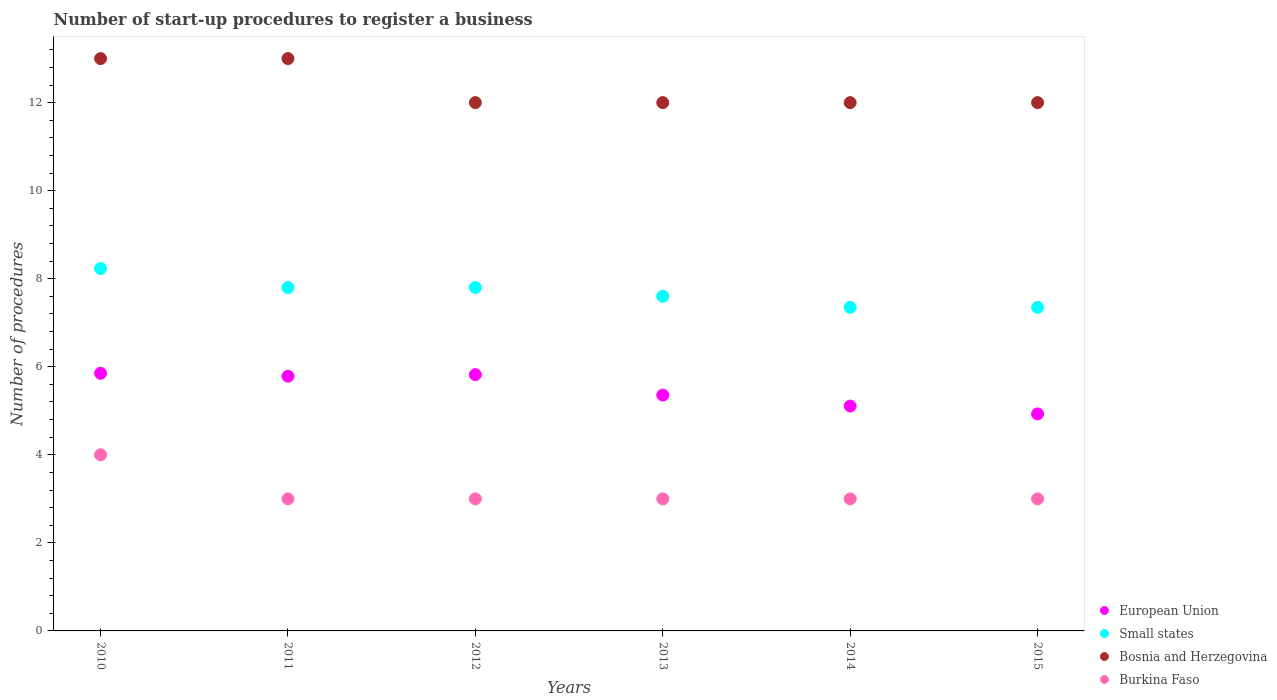Is the number of dotlines equal to the number of legend labels?
Make the answer very short. Yes. What is the number of procedures required to register a business in European Union in 2010?
Ensure brevity in your answer.  5.85. Across all years, what is the maximum number of procedures required to register a business in Small states?
Offer a terse response. 8.23. Across all years, what is the minimum number of procedures required to register a business in Small states?
Give a very brief answer. 7.35. What is the total number of procedures required to register a business in Small states in the graph?
Provide a short and direct response. 46.13. What is the difference between the number of procedures required to register a business in Burkina Faso in 2011 and that in 2012?
Offer a very short reply. 0. What is the difference between the number of procedures required to register a business in Burkina Faso in 2011 and the number of procedures required to register a business in Small states in 2015?
Provide a short and direct response. -4.35. What is the average number of procedures required to register a business in European Union per year?
Provide a succinct answer. 5.48. In the year 2012, what is the difference between the number of procedures required to register a business in Burkina Faso and number of procedures required to register a business in Small states?
Offer a terse response. -4.8. What is the ratio of the number of procedures required to register a business in European Union in 2013 to that in 2014?
Provide a succinct answer. 1.05. Is the number of procedures required to register a business in Small states in 2010 less than that in 2013?
Provide a succinct answer. No. What is the difference between the highest and the second highest number of procedures required to register a business in Small states?
Offer a very short reply. 0.43. What is the difference between the highest and the lowest number of procedures required to register a business in Small states?
Provide a short and direct response. 0.88. Is it the case that in every year, the sum of the number of procedures required to register a business in Small states and number of procedures required to register a business in Bosnia and Herzegovina  is greater than the sum of number of procedures required to register a business in European Union and number of procedures required to register a business in Burkina Faso?
Your response must be concise. Yes. Is it the case that in every year, the sum of the number of procedures required to register a business in Small states and number of procedures required to register a business in Bosnia and Herzegovina  is greater than the number of procedures required to register a business in European Union?
Ensure brevity in your answer.  Yes. Is the number of procedures required to register a business in Burkina Faso strictly less than the number of procedures required to register a business in European Union over the years?
Offer a very short reply. Yes. What is the difference between two consecutive major ticks on the Y-axis?
Your answer should be compact. 2. Does the graph contain any zero values?
Your answer should be very brief. No. Where does the legend appear in the graph?
Your answer should be very brief. Bottom right. How many legend labels are there?
Make the answer very short. 4. What is the title of the graph?
Give a very brief answer. Number of start-up procedures to register a business. What is the label or title of the X-axis?
Provide a succinct answer. Years. What is the label or title of the Y-axis?
Make the answer very short. Number of procedures. What is the Number of procedures of European Union in 2010?
Give a very brief answer. 5.85. What is the Number of procedures in Small states in 2010?
Your answer should be very brief. 8.23. What is the Number of procedures in Bosnia and Herzegovina in 2010?
Make the answer very short. 13. What is the Number of procedures of European Union in 2011?
Keep it short and to the point. 5.79. What is the Number of procedures in European Union in 2012?
Offer a very short reply. 5.82. What is the Number of procedures of Small states in 2012?
Your response must be concise. 7.8. What is the Number of procedures of Burkina Faso in 2012?
Offer a very short reply. 3. What is the Number of procedures of European Union in 2013?
Keep it short and to the point. 5.36. What is the Number of procedures in Bosnia and Herzegovina in 2013?
Your answer should be compact. 12. What is the Number of procedures of Burkina Faso in 2013?
Provide a succinct answer. 3. What is the Number of procedures in European Union in 2014?
Offer a very short reply. 5.11. What is the Number of procedures in Small states in 2014?
Keep it short and to the point. 7.35. What is the Number of procedures of Bosnia and Herzegovina in 2014?
Ensure brevity in your answer.  12. What is the Number of procedures in Burkina Faso in 2014?
Make the answer very short. 3. What is the Number of procedures of European Union in 2015?
Your response must be concise. 4.93. What is the Number of procedures of Small states in 2015?
Your response must be concise. 7.35. Across all years, what is the maximum Number of procedures in European Union?
Keep it short and to the point. 5.85. Across all years, what is the maximum Number of procedures of Small states?
Your answer should be compact. 8.23. Across all years, what is the maximum Number of procedures of Burkina Faso?
Provide a succinct answer. 4. Across all years, what is the minimum Number of procedures in European Union?
Provide a short and direct response. 4.93. Across all years, what is the minimum Number of procedures in Small states?
Your answer should be very brief. 7.35. Across all years, what is the minimum Number of procedures in Bosnia and Herzegovina?
Keep it short and to the point. 12. What is the total Number of procedures of European Union in the graph?
Make the answer very short. 32.85. What is the total Number of procedures of Small states in the graph?
Your answer should be compact. 46.13. What is the difference between the Number of procedures of European Union in 2010 and that in 2011?
Ensure brevity in your answer.  0.07. What is the difference between the Number of procedures in Small states in 2010 and that in 2011?
Make the answer very short. 0.43. What is the difference between the Number of procedures in Burkina Faso in 2010 and that in 2011?
Give a very brief answer. 1. What is the difference between the Number of procedures of European Union in 2010 and that in 2012?
Your answer should be compact. 0.03. What is the difference between the Number of procedures in Small states in 2010 and that in 2012?
Provide a succinct answer. 0.43. What is the difference between the Number of procedures of Burkina Faso in 2010 and that in 2012?
Offer a terse response. 1. What is the difference between the Number of procedures in European Union in 2010 and that in 2013?
Your response must be concise. 0.49. What is the difference between the Number of procedures in Small states in 2010 and that in 2013?
Your answer should be very brief. 0.63. What is the difference between the Number of procedures of Burkina Faso in 2010 and that in 2013?
Offer a very short reply. 1. What is the difference between the Number of procedures in European Union in 2010 and that in 2014?
Offer a very short reply. 0.74. What is the difference between the Number of procedures of Small states in 2010 and that in 2014?
Provide a succinct answer. 0.88. What is the difference between the Number of procedures in Burkina Faso in 2010 and that in 2014?
Keep it short and to the point. 1. What is the difference between the Number of procedures of European Union in 2010 and that in 2015?
Offer a terse response. 0.92. What is the difference between the Number of procedures in Small states in 2010 and that in 2015?
Offer a terse response. 0.88. What is the difference between the Number of procedures of Burkina Faso in 2010 and that in 2015?
Your answer should be very brief. 1. What is the difference between the Number of procedures of European Union in 2011 and that in 2012?
Give a very brief answer. -0.04. What is the difference between the Number of procedures of Small states in 2011 and that in 2012?
Offer a very short reply. 0. What is the difference between the Number of procedures in Bosnia and Herzegovina in 2011 and that in 2012?
Make the answer very short. 1. What is the difference between the Number of procedures of European Union in 2011 and that in 2013?
Provide a succinct answer. 0.43. What is the difference between the Number of procedures of European Union in 2011 and that in 2014?
Your answer should be compact. 0.68. What is the difference between the Number of procedures in Small states in 2011 and that in 2014?
Give a very brief answer. 0.45. What is the difference between the Number of procedures in Burkina Faso in 2011 and that in 2014?
Offer a terse response. 0. What is the difference between the Number of procedures in European Union in 2011 and that in 2015?
Offer a terse response. 0.86. What is the difference between the Number of procedures of Small states in 2011 and that in 2015?
Keep it short and to the point. 0.45. What is the difference between the Number of procedures of European Union in 2012 and that in 2013?
Ensure brevity in your answer.  0.46. What is the difference between the Number of procedures in Bosnia and Herzegovina in 2012 and that in 2013?
Give a very brief answer. 0. What is the difference between the Number of procedures of European Union in 2012 and that in 2014?
Offer a terse response. 0.71. What is the difference between the Number of procedures of Small states in 2012 and that in 2014?
Give a very brief answer. 0.45. What is the difference between the Number of procedures of Bosnia and Herzegovina in 2012 and that in 2014?
Offer a terse response. 0. What is the difference between the Number of procedures in Burkina Faso in 2012 and that in 2014?
Give a very brief answer. 0. What is the difference between the Number of procedures in European Union in 2012 and that in 2015?
Your answer should be very brief. 0.89. What is the difference between the Number of procedures in Small states in 2012 and that in 2015?
Your answer should be compact. 0.45. What is the difference between the Number of procedures in Bosnia and Herzegovina in 2012 and that in 2015?
Your answer should be compact. 0. What is the difference between the Number of procedures in Small states in 2013 and that in 2014?
Provide a short and direct response. 0.25. What is the difference between the Number of procedures of Bosnia and Herzegovina in 2013 and that in 2014?
Provide a succinct answer. 0. What is the difference between the Number of procedures of Burkina Faso in 2013 and that in 2014?
Offer a very short reply. 0. What is the difference between the Number of procedures of European Union in 2013 and that in 2015?
Your answer should be compact. 0.43. What is the difference between the Number of procedures in Small states in 2013 and that in 2015?
Give a very brief answer. 0.25. What is the difference between the Number of procedures in European Union in 2014 and that in 2015?
Offer a terse response. 0.18. What is the difference between the Number of procedures in Small states in 2014 and that in 2015?
Offer a very short reply. 0. What is the difference between the Number of procedures in European Union in 2010 and the Number of procedures in Small states in 2011?
Provide a succinct answer. -1.95. What is the difference between the Number of procedures in European Union in 2010 and the Number of procedures in Bosnia and Herzegovina in 2011?
Provide a succinct answer. -7.15. What is the difference between the Number of procedures of European Union in 2010 and the Number of procedures of Burkina Faso in 2011?
Your answer should be compact. 2.85. What is the difference between the Number of procedures in Small states in 2010 and the Number of procedures in Bosnia and Herzegovina in 2011?
Keep it short and to the point. -4.77. What is the difference between the Number of procedures in Small states in 2010 and the Number of procedures in Burkina Faso in 2011?
Offer a terse response. 5.23. What is the difference between the Number of procedures in Bosnia and Herzegovina in 2010 and the Number of procedures in Burkina Faso in 2011?
Offer a terse response. 10. What is the difference between the Number of procedures in European Union in 2010 and the Number of procedures in Small states in 2012?
Keep it short and to the point. -1.95. What is the difference between the Number of procedures in European Union in 2010 and the Number of procedures in Bosnia and Herzegovina in 2012?
Make the answer very short. -6.15. What is the difference between the Number of procedures in European Union in 2010 and the Number of procedures in Burkina Faso in 2012?
Ensure brevity in your answer.  2.85. What is the difference between the Number of procedures of Small states in 2010 and the Number of procedures of Bosnia and Herzegovina in 2012?
Ensure brevity in your answer.  -3.77. What is the difference between the Number of procedures of Small states in 2010 and the Number of procedures of Burkina Faso in 2012?
Keep it short and to the point. 5.23. What is the difference between the Number of procedures in European Union in 2010 and the Number of procedures in Small states in 2013?
Your answer should be compact. -1.75. What is the difference between the Number of procedures of European Union in 2010 and the Number of procedures of Bosnia and Herzegovina in 2013?
Give a very brief answer. -6.15. What is the difference between the Number of procedures in European Union in 2010 and the Number of procedures in Burkina Faso in 2013?
Offer a very short reply. 2.85. What is the difference between the Number of procedures in Small states in 2010 and the Number of procedures in Bosnia and Herzegovina in 2013?
Your response must be concise. -3.77. What is the difference between the Number of procedures in Small states in 2010 and the Number of procedures in Burkina Faso in 2013?
Ensure brevity in your answer.  5.23. What is the difference between the Number of procedures in Bosnia and Herzegovina in 2010 and the Number of procedures in Burkina Faso in 2013?
Ensure brevity in your answer.  10. What is the difference between the Number of procedures of European Union in 2010 and the Number of procedures of Small states in 2014?
Make the answer very short. -1.5. What is the difference between the Number of procedures of European Union in 2010 and the Number of procedures of Bosnia and Herzegovina in 2014?
Make the answer very short. -6.15. What is the difference between the Number of procedures in European Union in 2010 and the Number of procedures in Burkina Faso in 2014?
Provide a succinct answer. 2.85. What is the difference between the Number of procedures of Small states in 2010 and the Number of procedures of Bosnia and Herzegovina in 2014?
Your response must be concise. -3.77. What is the difference between the Number of procedures in Small states in 2010 and the Number of procedures in Burkina Faso in 2014?
Provide a short and direct response. 5.23. What is the difference between the Number of procedures in Bosnia and Herzegovina in 2010 and the Number of procedures in Burkina Faso in 2014?
Make the answer very short. 10. What is the difference between the Number of procedures in European Union in 2010 and the Number of procedures in Small states in 2015?
Keep it short and to the point. -1.5. What is the difference between the Number of procedures of European Union in 2010 and the Number of procedures of Bosnia and Herzegovina in 2015?
Provide a short and direct response. -6.15. What is the difference between the Number of procedures of European Union in 2010 and the Number of procedures of Burkina Faso in 2015?
Make the answer very short. 2.85. What is the difference between the Number of procedures in Small states in 2010 and the Number of procedures in Bosnia and Herzegovina in 2015?
Give a very brief answer. -3.77. What is the difference between the Number of procedures of Small states in 2010 and the Number of procedures of Burkina Faso in 2015?
Keep it short and to the point. 5.23. What is the difference between the Number of procedures of European Union in 2011 and the Number of procedures of Small states in 2012?
Your answer should be very brief. -2.01. What is the difference between the Number of procedures in European Union in 2011 and the Number of procedures in Bosnia and Herzegovina in 2012?
Give a very brief answer. -6.21. What is the difference between the Number of procedures of European Union in 2011 and the Number of procedures of Burkina Faso in 2012?
Ensure brevity in your answer.  2.79. What is the difference between the Number of procedures of Small states in 2011 and the Number of procedures of Burkina Faso in 2012?
Offer a terse response. 4.8. What is the difference between the Number of procedures of Bosnia and Herzegovina in 2011 and the Number of procedures of Burkina Faso in 2012?
Provide a short and direct response. 10. What is the difference between the Number of procedures of European Union in 2011 and the Number of procedures of Small states in 2013?
Offer a very short reply. -1.81. What is the difference between the Number of procedures in European Union in 2011 and the Number of procedures in Bosnia and Herzegovina in 2013?
Your answer should be very brief. -6.21. What is the difference between the Number of procedures in European Union in 2011 and the Number of procedures in Burkina Faso in 2013?
Your response must be concise. 2.79. What is the difference between the Number of procedures of Small states in 2011 and the Number of procedures of Bosnia and Herzegovina in 2013?
Make the answer very short. -4.2. What is the difference between the Number of procedures in Small states in 2011 and the Number of procedures in Burkina Faso in 2013?
Your answer should be compact. 4.8. What is the difference between the Number of procedures in European Union in 2011 and the Number of procedures in Small states in 2014?
Offer a terse response. -1.56. What is the difference between the Number of procedures of European Union in 2011 and the Number of procedures of Bosnia and Herzegovina in 2014?
Provide a short and direct response. -6.21. What is the difference between the Number of procedures in European Union in 2011 and the Number of procedures in Burkina Faso in 2014?
Make the answer very short. 2.79. What is the difference between the Number of procedures in Small states in 2011 and the Number of procedures in Bosnia and Herzegovina in 2014?
Offer a terse response. -4.2. What is the difference between the Number of procedures of European Union in 2011 and the Number of procedures of Small states in 2015?
Your response must be concise. -1.56. What is the difference between the Number of procedures in European Union in 2011 and the Number of procedures in Bosnia and Herzegovina in 2015?
Keep it short and to the point. -6.21. What is the difference between the Number of procedures of European Union in 2011 and the Number of procedures of Burkina Faso in 2015?
Ensure brevity in your answer.  2.79. What is the difference between the Number of procedures of Small states in 2011 and the Number of procedures of Burkina Faso in 2015?
Offer a very short reply. 4.8. What is the difference between the Number of procedures in European Union in 2012 and the Number of procedures in Small states in 2013?
Your answer should be very brief. -1.78. What is the difference between the Number of procedures of European Union in 2012 and the Number of procedures of Bosnia and Herzegovina in 2013?
Provide a short and direct response. -6.18. What is the difference between the Number of procedures in European Union in 2012 and the Number of procedures in Burkina Faso in 2013?
Offer a very short reply. 2.82. What is the difference between the Number of procedures in Small states in 2012 and the Number of procedures in Bosnia and Herzegovina in 2013?
Your answer should be compact. -4.2. What is the difference between the Number of procedures of Bosnia and Herzegovina in 2012 and the Number of procedures of Burkina Faso in 2013?
Your response must be concise. 9. What is the difference between the Number of procedures in European Union in 2012 and the Number of procedures in Small states in 2014?
Offer a very short reply. -1.53. What is the difference between the Number of procedures in European Union in 2012 and the Number of procedures in Bosnia and Herzegovina in 2014?
Keep it short and to the point. -6.18. What is the difference between the Number of procedures in European Union in 2012 and the Number of procedures in Burkina Faso in 2014?
Give a very brief answer. 2.82. What is the difference between the Number of procedures in Small states in 2012 and the Number of procedures in Bosnia and Herzegovina in 2014?
Offer a terse response. -4.2. What is the difference between the Number of procedures in Small states in 2012 and the Number of procedures in Burkina Faso in 2014?
Provide a succinct answer. 4.8. What is the difference between the Number of procedures in Bosnia and Herzegovina in 2012 and the Number of procedures in Burkina Faso in 2014?
Offer a terse response. 9. What is the difference between the Number of procedures in European Union in 2012 and the Number of procedures in Small states in 2015?
Make the answer very short. -1.53. What is the difference between the Number of procedures in European Union in 2012 and the Number of procedures in Bosnia and Herzegovina in 2015?
Your response must be concise. -6.18. What is the difference between the Number of procedures of European Union in 2012 and the Number of procedures of Burkina Faso in 2015?
Keep it short and to the point. 2.82. What is the difference between the Number of procedures of European Union in 2013 and the Number of procedures of Small states in 2014?
Your response must be concise. -1.99. What is the difference between the Number of procedures in European Union in 2013 and the Number of procedures in Bosnia and Herzegovina in 2014?
Ensure brevity in your answer.  -6.64. What is the difference between the Number of procedures in European Union in 2013 and the Number of procedures in Burkina Faso in 2014?
Ensure brevity in your answer.  2.36. What is the difference between the Number of procedures of Small states in 2013 and the Number of procedures of Bosnia and Herzegovina in 2014?
Give a very brief answer. -4.4. What is the difference between the Number of procedures in Small states in 2013 and the Number of procedures in Burkina Faso in 2014?
Your answer should be very brief. 4.6. What is the difference between the Number of procedures in European Union in 2013 and the Number of procedures in Small states in 2015?
Make the answer very short. -1.99. What is the difference between the Number of procedures of European Union in 2013 and the Number of procedures of Bosnia and Herzegovina in 2015?
Provide a succinct answer. -6.64. What is the difference between the Number of procedures of European Union in 2013 and the Number of procedures of Burkina Faso in 2015?
Your answer should be very brief. 2.36. What is the difference between the Number of procedures in Small states in 2013 and the Number of procedures in Burkina Faso in 2015?
Make the answer very short. 4.6. What is the difference between the Number of procedures in European Union in 2014 and the Number of procedures in Small states in 2015?
Your answer should be very brief. -2.24. What is the difference between the Number of procedures of European Union in 2014 and the Number of procedures of Bosnia and Herzegovina in 2015?
Ensure brevity in your answer.  -6.89. What is the difference between the Number of procedures in European Union in 2014 and the Number of procedures in Burkina Faso in 2015?
Provide a short and direct response. 2.11. What is the difference between the Number of procedures in Small states in 2014 and the Number of procedures in Bosnia and Herzegovina in 2015?
Provide a succinct answer. -4.65. What is the difference between the Number of procedures in Small states in 2014 and the Number of procedures in Burkina Faso in 2015?
Provide a succinct answer. 4.35. What is the difference between the Number of procedures in Bosnia and Herzegovina in 2014 and the Number of procedures in Burkina Faso in 2015?
Offer a very short reply. 9. What is the average Number of procedures of European Union per year?
Give a very brief answer. 5.48. What is the average Number of procedures in Small states per year?
Your answer should be very brief. 7.69. What is the average Number of procedures of Bosnia and Herzegovina per year?
Provide a succinct answer. 12.33. What is the average Number of procedures of Burkina Faso per year?
Give a very brief answer. 3.17. In the year 2010, what is the difference between the Number of procedures in European Union and Number of procedures in Small states?
Offer a very short reply. -2.38. In the year 2010, what is the difference between the Number of procedures of European Union and Number of procedures of Bosnia and Herzegovina?
Offer a very short reply. -7.15. In the year 2010, what is the difference between the Number of procedures in European Union and Number of procedures in Burkina Faso?
Your response must be concise. 1.85. In the year 2010, what is the difference between the Number of procedures of Small states and Number of procedures of Bosnia and Herzegovina?
Provide a succinct answer. -4.77. In the year 2010, what is the difference between the Number of procedures in Small states and Number of procedures in Burkina Faso?
Keep it short and to the point. 4.23. In the year 2010, what is the difference between the Number of procedures of Bosnia and Herzegovina and Number of procedures of Burkina Faso?
Your answer should be very brief. 9. In the year 2011, what is the difference between the Number of procedures in European Union and Number of procedures in Small states?
Ensure brevity in your answer.  -2.01. In the year 2011, what is the difference between the Number of procedures in European Union and Number of procedures in Bosnia and Herzegovina?
Keep it short and to the point. -7.21. In the year 2011, what is the difference between the Number of procedures in European Union and Number of procedures in Burkina Faso?
Provide a short and direct response. 2.79. In the year 2011, what is the difference between the Number of procedures of Small states and Number of procedures of Burkina Faso?
Keep it short and to the point. 4.8. In the year 2012, what is the difference between the Number of procedures of European Union and Number of procedures of Small states?
Keep it short and to the point. -1.98. In the year 2012, what is the difference between the Number of procedures of European Union and Number of procedures of Bosnia and Herzegovina?
Your response must be concise. -6.18. In the year 2012, what is the difference between the Number of procedures in European Union and Number of procedures in Burkina Faso?
Offer a terse response. 2.82. In the year 2013, what is the difference between the Number of procedures of European Union and Number of procedures of Small states?
Give a very brief answer. -2.24. In the year 2013, what is the difference between the Number of procedures of European Union and Number of procedures of Bosnia and Herzegovina?
Make the answer very short. -6.64. In the year 2013, what is the difference between the Number of procedures in European Union and Number of procedures in Burkina Faso?
Provide a short and direct response. 2.36. In the year 2013, what is the difference between the Number of procedures in Bosnia and Herzegovina and Number of procedures in Burkina Faso?
Your answer should be compact. 9. In the year 2014, what is the difference between the Number of procedures in European Union and Number of procedures in Small states?
Keep it short and to the point. -2.24. In the year 2014, what is the difference between the Number of procedures in European Union and Number of procedures in Bosnia and Herzegovina?
Ensure brevity in your answer.  -6.89. In the year 2014, what is the difference between the Number of procedures of European Union and Number of procedures of Burkina Faso?
Provide a succinct answer. 2.11. In the year 2014, what is the difference between the Number of procedures of Small states and Number of procedures of Bosnia and Herzegovina?
Your response must be concise. -4.65. In the year 2014, what is the difference between the Number of procedures in Small states and Number of procedures in Burkina Faso?
Make the answer very short. 4.35. In the year 2015, what is the difference between the Number of procedures in European Union and Number of procedures in Small states?
Offer a terse response. -2.42. In the year 2015, what is the difference between the Number of procedures of European Union and Number of procedures of Bosnia and Herzegovina?
Give a very brief answer. -7.07. In the year 2015, what is the difference between the Number of procedures of European Union and Number of procedures of Burkina Faso?
Give a very brief answer. 1.93. In the year 2015, what is the difference between the Number of procedures in Small states and Number of procedures in Bosnia and Herzegovina?
Offer a terse response. -4.65. In the year 2015, what is the difference between the Number of procedures in Small states and Number of procedures in Burkina Faso?
Your answer should be compact. 4.35. What is the ratio of the Number of procedures in European Union in 2010 to that in 2011?
Provide a short and direct response. 1.01. What is the ratio of the Number of procedures of Small states in 2010 to that in 2011?
Make the answer very short. 1.06. What is the ratio of the Number of procedures of Small states in 2010 to that in 2012?
Give a very brief answer. 1.06. What is the ratio of the Number of procedures of Bosnia and Herzegovina in 2010 to that in 2012?
Your response must be concise. 1.08. What is the ratio of the Number of procedures of European Union in 2010 to that in 2013?
Make the answer very short. 1.09. What is the ratio of the Number of procedures in Small states in 2010 to that in 2013?
Offer a terse response. 1.08. What is the ratio of the Number of procedures of European Union in 2010 to that in 2014?
Keep it short and to the point. 1.15. What is the ratio of the Number of procedures in Small states in 2010 to that in 2014?
Offer a terse response. 1.12. What is the ratio of the Number of procedures in Burkina Faso in 2010 to that in 2014?
Provide a short and direct response. 1.33. What is the ratio of the Number of procedures in European Union in 2010 to that in 2015?
Provide a short and direct response. 1.19. What is the ratio of the Number of procedures in Small states in 2010 to that in 2015?
Provide a short and direct response. 1.12. What is the ratio of the Number of procedures of Bosnia and Herzegovina in 2010 to that in 2015?
Ensure brevity in your answer.  1.08. What is the ratio of the Number of procedures in Burkina Faso in 2010 to that in 2015?
Make the answer very short. 1.33. What is the ratio of the Number of procedures of Small states in 2011 to that in 2012?
Give a very brief answer. 1. What is the ratio of the Number of procedures of Bosnia and Herzegovina in 2011 to that in 2012?
Your answer should be compact. 1.08. What is the ratio of the Number of procedures in Burkina Faso in 2011 to that in 2012?
Make the answer very short. 1. What is the ratio of the Number of procedures of Small states in 2011 to that in 2013?
Your answer should be very brief. 1.03. What is the ratio of the Number of procedures of Bosnia and Herzegovina in 2011 to that in 2013?
Ensure brevity in your answer.  1.08. What is the ratio of the Number of procedures of Burkina Faso in 2011 to that in 2013?
Offer a very short reply. 1. What is the ratio of the Number of procedures in European Union in 2011 to that in 2014?
Offer a very short reply. 1.13. What is the ratio of the Number of procedures of Small states in 2011 to that in 2014?
Your response must be concise. 1.06. What is the ratio of the Number of procedures in Bosnia and Herzegovina in 2011 to that in 2014?
Provide a succinct answer. 1.08. What is the ratio of the Number of procedures in European Union in 2011 to that in 2015?
Your answer should be very brief. 1.17. What is the ratio of the Number of procedures in Small states in 2011 to that in 2015?
Provide a short and direct response. 1.06. What is the ratio of the Number of procedures of Bosnia and Herzegovina in 2011 to that in 2015?
Give a very brief answer. 1.08. What is the ratio of the Number of procedures in Burkina Faso in 2011 to that in 2015?
Offer a very short reply. 1. What is the ratio of the Number of procedures in European Union in 2012 to that in 2013?
Give a very brief answer. 1.09. What is the ratio of the Number of procedures of Small states in 2012 to that in 2013?
Offer a very short reply. 1.03. What is the ratio of the Number of procedures in Burkina Faso in 2012 to that in 2013?
Offer a terse response. 1. What is the ratio of the Number of procedures of European Union in 2012 to that in 2014?
Keep it short and to the point. 1.14. What is the ratio of the Number of procedures of Small states in 2012 to that in 2014?
Give a very brief answer. 1.06. What is the ratio of the Number of procedures of European Union in 2012 to that in 2015?
Your answer should be very brief. 1.18. What is the ratio of the Number of procedures in Small states in 2012 to that in 2015?
Provide a short and direct response. 1.06. What is the ratio of the Number of procedures of Burkina Faso in 2012 to that in 2015?
Ensure brevity in your answer.  1. What is the ratio of the Number of procedures in European Union in 2013 to that in 2014?
Your response must be concise. 1.05. What is the ratio of the Number of procedures of Small states in 2013 to that in 2014?
Make the answer very short. 1.03. What is the ratio of the Number of procedures of European Union in 2013 to that in 2015?
Provide a succinct answer. 1.09. What is the ratio of the Number of procedures of Small states in 2013 to that in 2015?
Your answer should be very brief. 1.03. What is the ratio of the Number of procedures of Bosnia and Herzegovina in 2013 to that in 2015?
Keep it short and to the point. 1. What is the ratio of the Number of procedures of European Union in 2014 to that in 2015?
Keep it short and to the point. 1.04. What is the ratio of the Number of procedures in Small states in 2014 to that in 2015?
Keep it short and to the point. 1. What is the ratio of the Number of procedures of Burkina Faso in 2014 to that in 2015?
Your answer should be very brief. 1. What is the difference between the highest and the second highest Number of procedures of European Union?
Ensure brevity in your answer.  0.03. What is the difference between the highest and the second highest Number of procedures in Small states?
Provide a short and direct response. 0.43. What is the difference between the highest and the second highest Number of procedures of Bosnia and Herzegovina?
Ensure brevity in your answer.  0. What is the difference between the highest and the lowest Number of procedures in European Union?
Provide a short and direct response. 0.92. What is the difference between the highest and the lowest Number of procedures in Small states?
Make the answer very short. 0.88. What is the difference between the highest and the lowest Number of procedures in Bosnia and Herzegovina?
Ensure brevity in your answer.  1. What is the difference between the highest and the lowest Number of procedures in Burkina Faso?
Your answer should be compact. 1. 